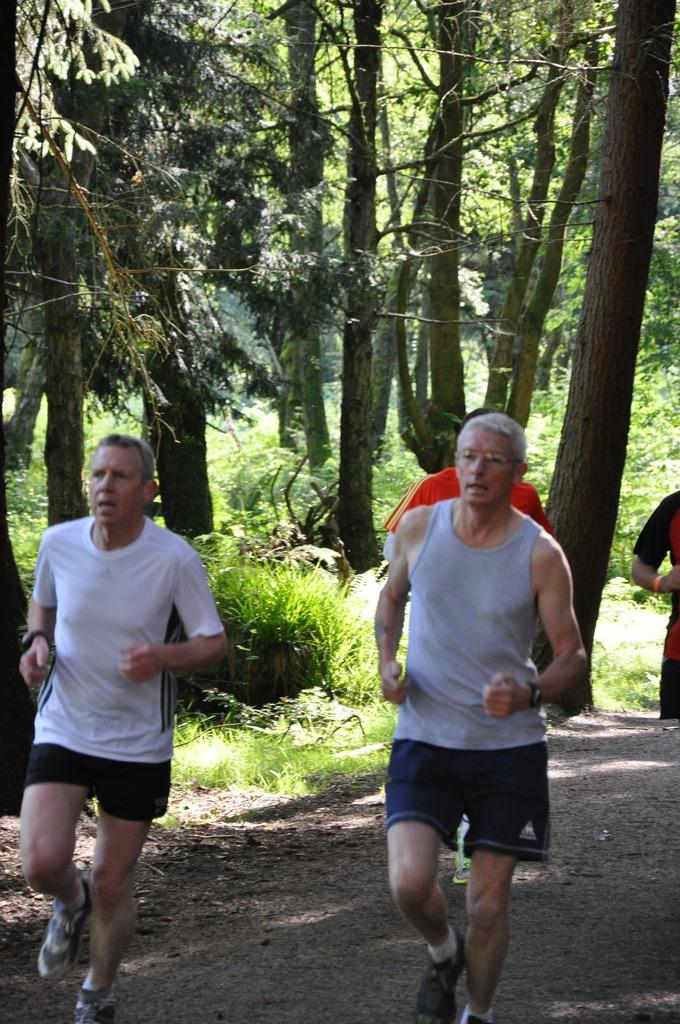What are the persons in the image doing? The persons in the image are walking on the road. What can be seen in the background behind the persons? There are trees and bushes visible behind the persons. What type of stamp can be seen on the person's forehead in the image? There is no stamp visible on any person's forehead in the image. 